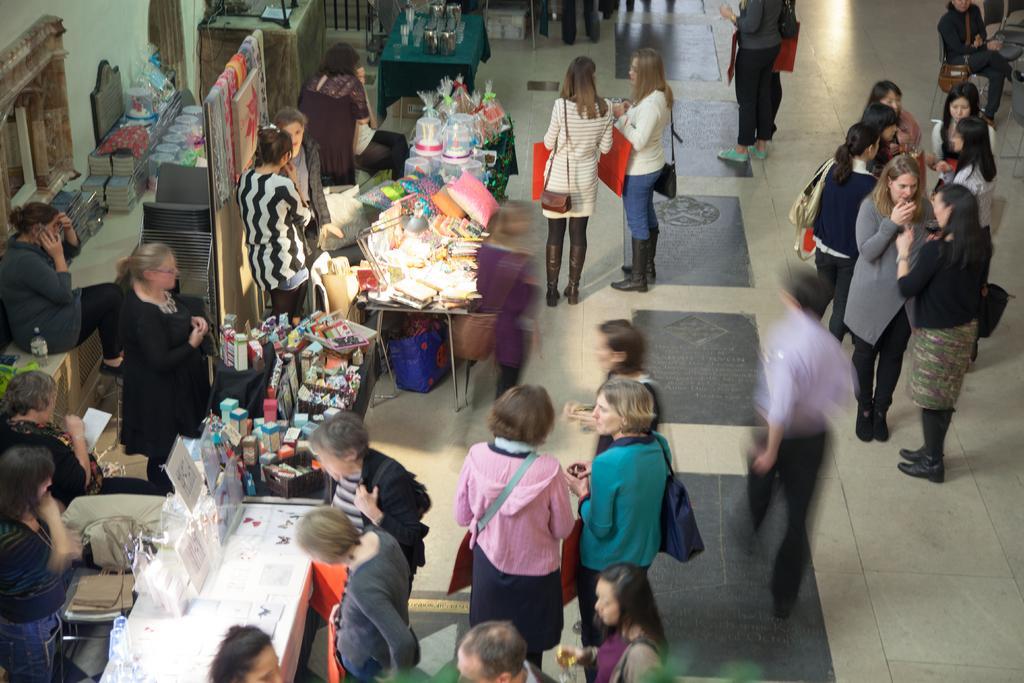Can you describe this image briefly? In this picture I can see a number of people standing on the surface. I can see stalls. I can see tables. I can see the chairs. I can see objects on the tables. 